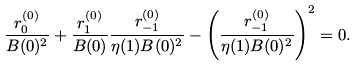<formula> <loc_0><loc_0><loc_500><loc_500>\frac { r _ { 0 } ^ { ( 0 ) } } { B ( 0 ) ^ { 2 } } + \frac { r _ { 1 } ^ { ( 0 ) } } { B ( 0 ) } \frac { r _ { - 1 } ^ { ( 0 ) } } { \eta ( 1 ) B ( 0 ) ^ { 2 } } - \left ( \frac { r _ { - 1 } ^ { ( 0 ) } } { \eta ( 1 ) B ( 0 ) ^ { 2 } } \right ) ^ { 2 } = 0 .</formula> 